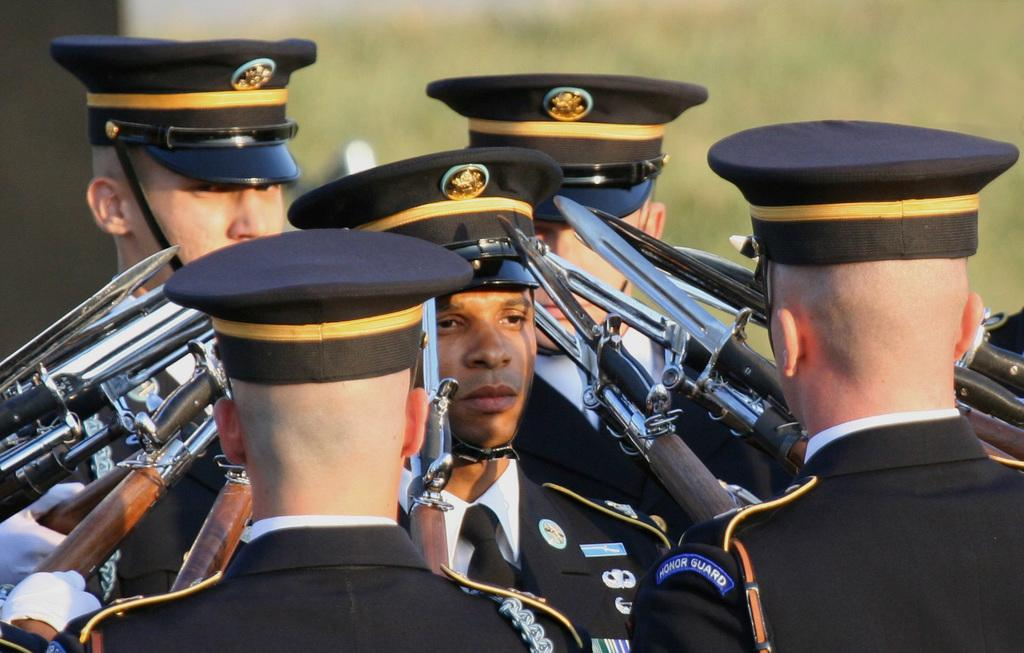What can be seen in the image regarding the people present? There is a group of people in the image. What are the people wearing that indicates their affiliation or purpose? The people are wearing uniforms and caps. What objects are visible that might be related to the group's purpose or activity? There are weapons visible in the image. Can you describe the background of the image? The background has a blurred view. What type of baby carrier can be seen in the image? There is no baby carrier present in the image. Can you tell me the name of the father in the image? There is no father or any individual person mentioned in the image; it only shows a group of people. 